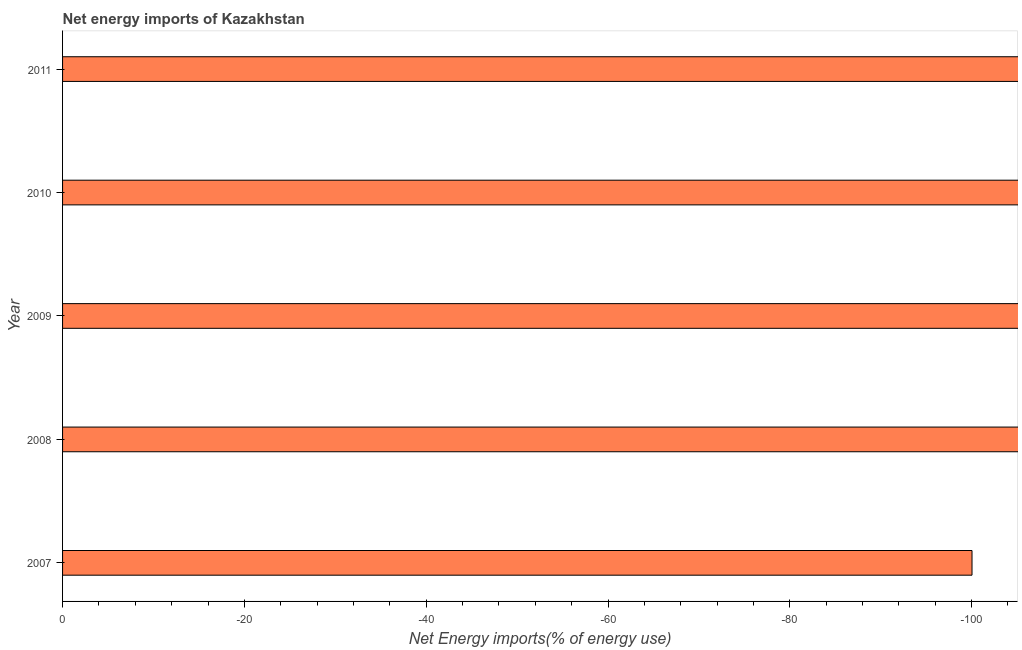Does the graph contain any zero values?
Offer a terse response. Yes. Does the graph contain grids?
Ensure brevity in your answer.  No. What is the title of the graph?
Offer a very short reply. Net energy imports of Kazakhstan. What is the label or title of the X-axis?
Give a very brief answer. Net Energy imports(% of energy use). What is the label or title of the Y-axis?
Offer a terse response. Year. Across all years, what is the minimum energy imports?
Provide a succinct answer. 0. What is the average energy imports per year?
Provide a succinct answer. 0. In how many years, is the energy imports greater than -84 %?
Your answer should be compact. 0. In how many years, is the energy imports greater than the average energy imports taken over all years?
Your answer should be compact. 0. How many bars are there?
Your answer should be very brief. 0. Are all the bars in the graph horizontal?
Your answer should be compact. Yes. What is the difference between two consecutive major ticks on the X-axis?
Keep it short and to the point. 20. What is the Net Energy imports(% of energy use) of 2007?
Offer a terse response. 0. What is the Net Energy imports(% of energy use) of 2009?
Your response must be concise. 0. What is the Net Energy imports(% of energy use) of 2010?
Your answer should be compact. 0. What is the Net Energy imports(% of energy use) of 2011?
Provide a short and direct response. 0. 